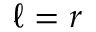Convert formula to latex. <formula><loc_0><loc_0><loc_500><loc_500>\ell = r</formula> 